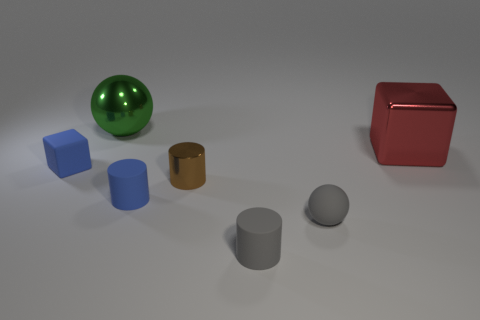Add 2 brown objects. How many objects exist? 9 Subtract all blocks. How many objects are left? 5 Add 5 matte objects. How many matte objects exist? 9 Subtract 1 blue cubes. How many objects are left? 6 Subtract all large green balls. Subtract all blue objects. How many objects are left? 4 Add 6 big red things. How many big red things are left? 7 